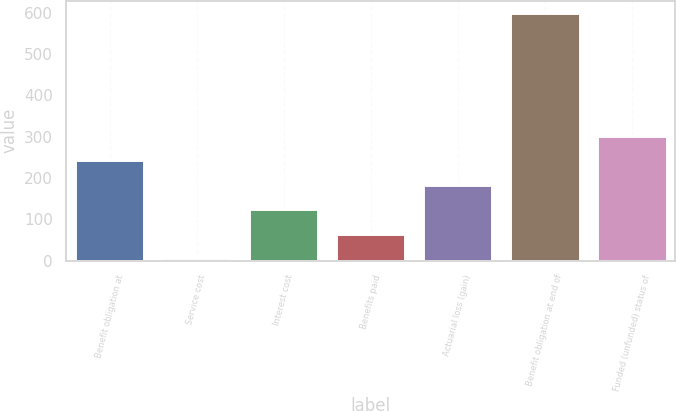Convert chart. <chart><loc_0><loc_0><loc_500><loc_500><bar_chart><fcel>Benefit obligation at<fcel>Service cost<fcel>Interest cost<fcel>Benefits paid<fcel>Actuarial loss (gain)<fcel>Benefit obligation at end of<fcel>Funded (unfunded) status of<nl><fcel>243.2<fcel>6<fcel>124.6<fcel>65.3<fcel>183.9<fcel>599<fcel>302.5<nl></chart> 